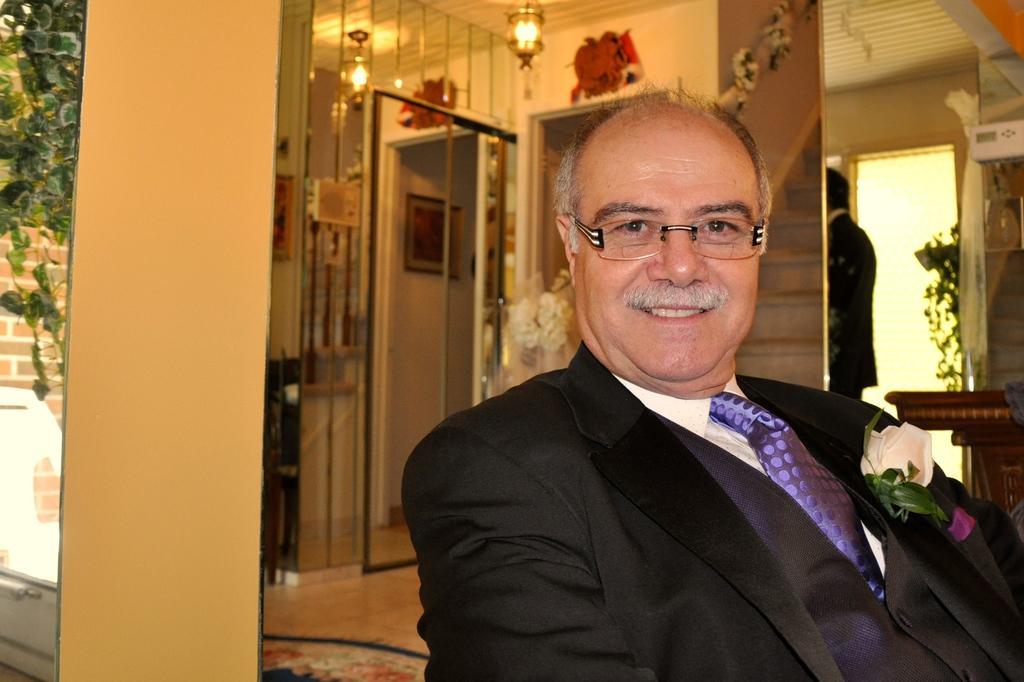Please provide a concise description of this image. This is an inside view. On the right side, I can see a man wearing a black color suit, smiling and giving pose for the picture. In the background, I can see wall and doors. To the wall a frame is attached. At the top I can see two lights are hanging to the roof. On the right side a person is standing. On the left side, I can see a wall and a creeper plant. 